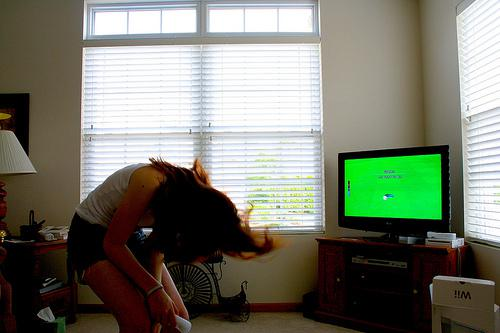Question: how many people are in the photo?
Choices:
A. One.
B. Two.
C. Three.
D. Four.
Answer with the letter. Answer: A Question: what is the girl doing in the picture?
Choices:
A. Watching television.
B. Painting.
C. Playing Wii.
D. Eating.
Answer with the letter. Answer: C Question: what color is the tv screen?
Choices:
A. Black.
B. Gray.
C. Green.
D. White.
Answer with the letter. Answer: C 